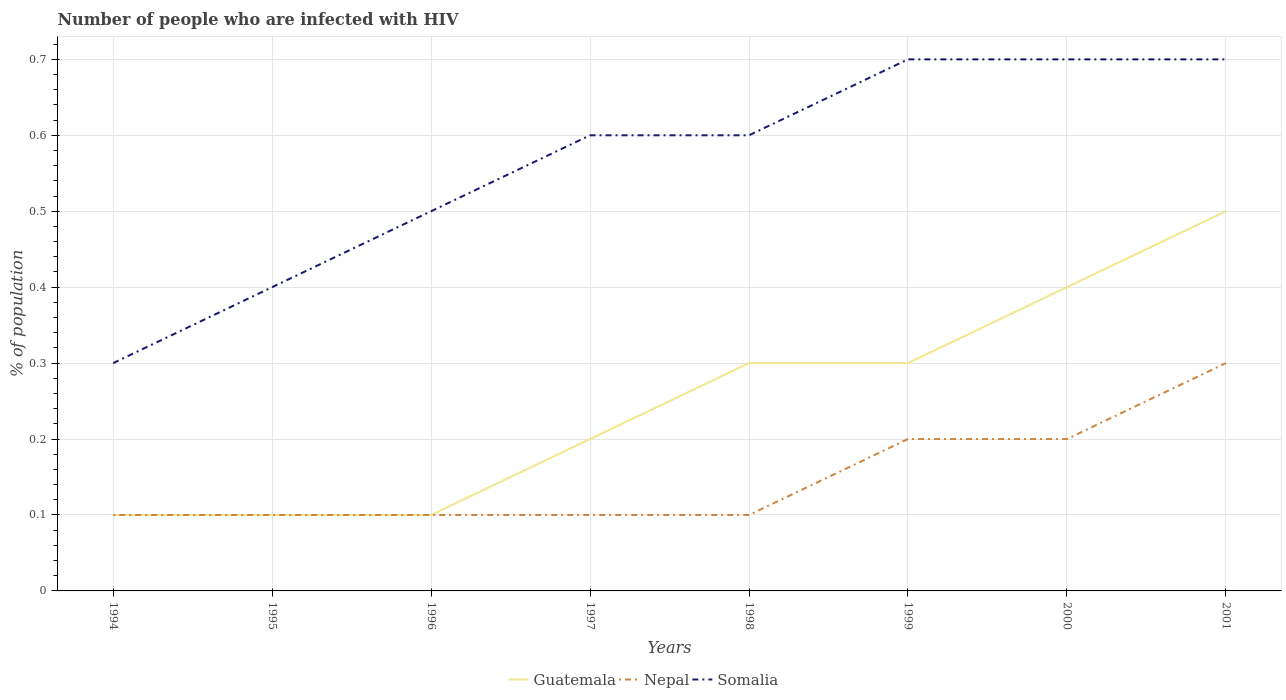How many different coloured lines are there?
Provide a short and direct response. 3. Does the line corresponding to Guatemala intersect with the line corresponding to Somalia?
Your response must be concise. No. Is the number of lines equal to the number of legend labels?
Keep it short and to the point. Yes. Across all years, what is the maximum percentage of HIV infected population in in Nepal?
Keep it short and to the point. 0.1. In which year was the percentage of HIV infected population in in Somalia maximum?
Your response must be concise. 1994. What is the difference between the highest and the second highest percentage of HIV infected population in in Somalia?
Provide a short and direct response. 0.4. What is the difference between the highest and the lowest percentage of HIV infected population in in Somalia?
Keep it short and to the point. 5. How many years are there in the graph?
Your answer should be very brief. 8. What is the difference between two consecutive major ticks on the Y-axis?
Your response must be concise. 0.1. What is the title of the graph?
Your answer should be compact. Number of people who are infected with HIV. What is the label or title of the X-axis?
Your response must be concise. Years. What is the label or title of the Y-axis?
Your response must be concise. % of population. What is the % of population of Guatemala in 1994?
Your response must be concise. 0.1. What is the % of population in Somalia in 1994?
Your answer should be compact. 0.3. What is the % of population of Guatemala in 1995?
Give a very brief answer. 0.1. What is the % of population in Nepal in 1995?
Provide a short and direct response. 0.1. What is the % of population in Somalia in 1995?
Your response must be concise. 0.4. What is the % of population of Nepal in 1996?
Keep it short and to the point. 0.1. What is the % of population of Guatemala in 1997?
Your response must be concise. 0.2. What is the % of population in Nepal in 1997?
Your answer should be very brief. 0.1. What is the % of population in Somalia in 1997?
Provide a short and direct response. 0.6. What is the % of population of Nepal in 1998?
Offer a terse response. 0.1. What is the % of population in Guatemala in 1999?
Your response must be concise. 0.3. What is the % of population of Somalia in 1999?
Give a very brief answer. 0.7. What is the % of population in Somalia in 2000?
Provide a short and direct response. 0.7. Across all years, what is the maximum % of population in Guatemala?
Offer a terse response. 0.5. Across all years, what is the minimum % of population in Nepal?
Give a very brief answer. 0.1. Across all years, what is the minimum % of population in Somalia?
Provide a short and direct response. 0.3. What is the total % of population of Guatemala in the graph?
Offer a terse response. 2. What is the difference between the % of population in Nepal in 1994 and that in 1995?
Your answer should be very brief. 0. What is the difference between the % of population of Somalia in 1994 and that in 1995?
Offer a terse response. -0.1. What is the difference between the % of population of Nepal in 1994 and that in 1996?
Provide a succinct answer. 0. What is the difference between the % of population of Somalia in 1994 and that in 1996?
Offer a very short reply. -0.2. What is the difference between the % of population of Guatemala in 1994 and that in 1997?
Make the answer very short. -0.1. What is the difference between the % of population of Somalia in 1994 and that in 1997?
Provide a succinct answer. -0.3. What is the difference between the % of population of Guatemala in 1994 and that in 1998?
Offer a very short reply. -0.2. What is the difference between the % of population of Guatemala in 1994 and that in 1999?
Your response must be concise. -0.2. What is the difference between the % of population in Nepal in 1994 and that in 1999?
Keep it short and to the point. -0.1. What is the difference between the % of population of Guatemala in 1994 and that in 2000?
Keep it short and to the point. -0.3. What is the difference between the % of population in Somalia in 1994 and that in 2000?
Your answer should be compact. -0.4. What is the difference between the % of population in Somalia in 1994 and that in 2001?
Offer a very short reply. -0.4. What is the difference between the % of population in Nepal in 1995 and that in 1996?
Your response must be concise. 0. What is the difference between the % of population of Guatemala in 1995 and that in 1998?
Your answer should be compact. -0.2. What is the difference between the % of population of Nepal in 1995 and that in 1999?
Provide a succinct answer. -0.1. What is the difference between the % of population in Guatemala in 1995 and that in 2001?
Ensure brevity in your answer.  -0.4. What is the difference between the % of population in Nepal in 1995 and that in 2001?
Keep it short and to the point. -0.2. What is the difference between the % of population of Guatemala in 1996 and that in 1997?
Offer a very short reply. -0.1. What is the difference between the % of population in Somalia in 1996 and that in 1997?
Your answer should be very brief. -0.1. What is the difference between the % of population of Somalia in 1996 and that in 1998?
Make the answer very short. -0.1. What is the difference between the % of population in Guatemala in 1996 and that in 1999?
Provide a succinct answer. -0.2. What is the difference between the % of population of Guatemala in 1996 and that in 2000?
Offer a terse response. -0.3. What is the difference between the % of population of Somalia in 1996 and that in 2000?
Offer a terse response. -0.2. What is the difference between the % of population of Nepal in 1996 and that in 2001?
Your answer should be very brief. -0.2. What is the difference between the % of population in Nepal in 1997 and that in 1999?
Your response must be concise. -0.1. What is the difference between the % of population of Somalia in 1997 and that in 1999?
Offer a terse response. -0.1. What is the difference between the % of population of Somalia in 1997 and that in 2000?
Make the answer very short. -0.1. What is the difference between the % of population of Guatemala in 1997 and that in 2001?
Your answer should be compact. -0.3. What is the difference between the % of population in Nepal in 1997 and that in 2001?
Provide a short and direct response. -0.2. What is the difference between the % of population in Somalia in 1997 and that in 2001?
Your answer should be very brief. -0.1. What is the difference between the % of population of Somalia in 1998 and that in 1999?
Your response must be concise. -0.1. What is the difference between the % of population in Guatemala in 1998 and that in 2000?
Make the answer very short. -0.1. What is the difference between the % of population of Nepal in 1998 and that in 2000?
Provide a succinct answer. -0.1. What is the difference between the % of population in Somalia in 1998 and that in 2001?
Provide a succinct answer. -0.1. What is the difference between the % of population of Guatemala in 1999 and that in 2000?
Offer a very short reply. -0.1. What is the difference between the % of population in Somalia in 1999 and that in 2000?
Offer a very short reply. 0. What is the difference between the % of population of Guatemala in 2000 and that in 2001?
Provide a succinct answer. -0.1. What is the difference between the % of population of Nepal in 2000 and that in 2001?
Ensure brevity in your answer.  -0.1. What is the difference between the % of population of Somalia in 2000 and that in 2001?
Offer a very short reply. 0. What is the difference between the % of population of Guatemala in 1994 and the % of population of Somalia in 1995?
Make the answer very short. -0.3. What is the difference between the % of population of Nepal in 1994 and the % of population of Somalia in 1995?
Ensure brevity in your answer.  -0.3. What is the difference between the % of population in Nepal in 1994 and the % of population in Somalia in 1996?
Your response must be concise. -0.4. What is the difference between the % of population of Guatemala in 1994 and the % of population of Nepal in 1997?
Make the answer very short. 0. What is the difference between the % of population in Guatemala in 1994 and the % of population in Somalia in 1997?
Make the answer very short. -0.5. What is the difference between the % of population in Guatemala in 1994 and the % of population in Somalia in 1998?
Provide a succinct answer. -0.5. What is the difference between the % of population in Nepal in 1994 and the % of population in Somalia in 1998?
Ensure brevity in your answer.  -0.5. What is the difference between the % of population of Guatemala in 1994 and the % of population of Somalia in 1999?
Ensure brevity in your answer.  -0.6. What is the difference between the % of population in Guatemala in 1994 and the % of population in Nepal in 2001?
Keep it short and to the point. -0.2. What is the difference between the % of population in Guatemala in 1994 and the % of population in Somalia in 2001?
Offer a very short reply. -0.6. What is the difference between the % of population in Nepal in 1995 and the % of population in Somalia in 1996?
Your answer should be very brief. -0.4. What is the difference between the % of population in Guatemala in 1995 and the % of population in Nepal in 1998?
Keep it short and to the point. 0. What is the difference between the % of population in Guatemala in 1995 and the % of population in Somalia in 1998?
Your answer should be compact. -0.5. What is the difference between the % of population in Guatemala in 1995 and the % of population in Somalia in 1999?
Ensure brevity in your answer.  -0.6. What is the difference between the % of population of Guatemala in 1995 and the % of population of Nepal in 2000?
Your answer should be compact. -0.1. What is the difference between the % of population in Nepal in 1995 and the % of population in Somalia in 2000?
Keep it short and to the point. -0.6. What is the difference between the % of population in Guatemala in 1995 and the % of population in Nepal in 2001?
Ensure brevity in your answer.  -0.2. What is the difference between the % of population of Guatemala in 1995 and the % of population of Somalia in 2001?
Ensure brevity in your answer.  -0.6. What is the difference between the % of population of Nepal in 1995 and the % of population of Somalia in 2001?
Provide a succinct answer. -0.6. What is the difference between the % of population of Guatemala in 1996 and the % of population of Nepal in 1997?
Ensure brevity in your answer.  0. What is the difference between the % of population of Guatemala in 1996 and the % of population of Somalia in 1997?
Your answer should be compact. -0.5. What is the difference between the % of population in Nepal in 1996 and the % of population in Somalia in 1998?
Offer a terse response. -0.5. What is the difference between the % of population in Nepal in 1996 and the % of population in Somalia in 1999?
Provide a short and direct response. -0.6. What is the difference between the % of population in Guatemala in 1996 and the % of population in Nepal in 2000?
Offer a very short reply. -0.1. What is the difference between the % of population in Nepal in 1996 and the % of population in Somalia in 2000?
Make the answer very short. -0.6. What is the difference between the % of population of Guatemala in 1996 and the % of population of Nepal in 2001?
Give a very brief answer. -0.2. What is the difference between the % of population in Nepal in 1996 and the % of population in Somalia in 2001?
Keep it short and to the point. -0.6. What is the difference between the % of population in Guatemala in 1997 and the % of population in Nepal in 1998?
Keep it short and to the point. 0.1. What is the difference between the % of population of Guatemala in 1997 and the % of population of Nepal in 1999?
Provide a short and direct response. 0. What is the difference between the % of population of Guatemala in 1997 and the % of population of Nepal in 2000?
Make the answer very short. 0. What is the difference between the % of population in Guatemala in 1997 and the % of population in Somalia in 2000?
Ensure brevity in your answer.  -0.5. What is the difference between the % of population of Nepal in 1997 and the % of population of Somalia in 2000?
Your response must be concise. -0.6. What is the difference between the % of population of Guatemala in 1997 and the % of population of Nepal in 2001?
Provide a succinct answer. -0.1. What is the difference between the % of population in Nepal in 1997 and the % of population in Somalia in 2001?
Give a very brief answer. -0.6. What is the difference between the % of population of Guatemala in 1998 and the % of population of Somalia in 1999?
Make the answer very short. -0.4. What is the difference between the % of population in Nepal in 1998 and the % of population in Somalia in 1999?
Your answer should be compact. -0.6. What is the difference between the % of population in Guatemala in 1998 and the % of population in Somalia in 2000?
Make the answer very short. -0.4. What is the difference between the % of population in Guatemala in 1998 and the % of population in Somalia in 2001?
Your answer should be very brief. -0.4. What is the difference between the % of population in Nepal in 1999 and the % of population in Somalia in 2000?
Your answer should be very brief. -0.5. What is the difference between the % of population in Guatemala in 1999 and the % of population in Nepal in 2001?
Provide a succinct answer. 0. What is the difference between the % of population in Guatemala in 1999 and the % of population in Somalia in 2001?
Your answer should be very brief. -0.4. What is the difference between the % of population of Guatemala in 2000 and the % of population of Nepal in 2001?
Keep it short and to the point. 0.1. What is the difference between the % of population of Guatemala in 2000 and the % of population of Somalia in 2001?
Give a very brief answer. -0.3. What is the average % of population in Guatemala per year?
Your answer should be very brief. 0.25. What is the average % of population of Somalia per year?
Ensure brevity in your answer.  0.56. In the year 1994, what is the difference between the % of population of Guatemala and % of population of Nepal?
Provide a succinct answer. 0. In the year 1994, what is the difference between the % of population in Guatemala and % of population in Somalia?
Make the answer very short. -0.2. In the year 1995, what is the difference between the % of population in Nepal and % of population in Somalia?
Keep it short and to the point. -0.3. In the year 1996, what is the difference between the % of population of Guatemala and % of population of Somalia?
Offer a very short reply. -0.4. In the year 1997, what is the difference between the % of population of Guatemala and % of population of Nepal?
Provide a succinct answer. 0.1. In the year 1997, what is the difference between the % of population of Nepal and % of population of Somalia?
Offer a terse response. -0.5. In the year 1998, what is the difference between the % of population of Guatemala and % of population of Nepal?
Offer a terse response. 0.2. In the year 1998, what is the difference between the % of population of Nepal and % of population of Somalia?
Offer a very short reply. -0.5. In the year 1999, what is the difference between the % of population of Guatemala and % of population of Somalia?
Provide a short and direct response. -0.4. In the year 2000, what is the difference between the % of population of Nepal and % of population of Somalia?
Your answer should be very brief. -0.5. In the year 2001, what is the difference between the % of population of Guatemala and % of population of Somalia?
Offer a very short reply. -0.2. What is the ratio of the % of population of Guatemala in 1994 to that in 1995?
Offer a terse response. 1. What is the ratio of the % of population of Nepal in 1994 to that in 1995?
Offer a very short reply. 1. What is the ratio of the % of population of Guatemala in 1994 to that in 1996?
Your response must be concise. 1. What is the ratio of the % of population of Guatemala in 1994 to that in 1997?
Keep it short and to the point. 0.5. What is the ratio of the % of population of Nepal in 1994 to that in 1997?
Your response must be concise. 1. What is the ratio of the % of population of Somalia in 1994 to that in 1997?
Provide a succinct answer. 0.5. What is the ratio of the % of population in Nepal in 1994 to that in 1998?
Keep it short and to the point. 1. What is the ratio of the % of population of Somalia in 1994 to that in 1998?
Keep it short and to the point. 0.5. What is the ratio of the % of population of Guatemala in 1994 to that in 1999?
Keep it short and to the point. 0.33. What is the ratio of the % of population in Somalia in 1994 to that in 1999?
Provide a succinct answer. 0.43. What is the ratio of the % of population in Nepal in 1994 to that in 2000?
Keep it short and to the point. 0.5. What is the ratio of the % of population in Somalia in 1994 to that in 2000?
Offer a terse response. 0.43. What is the ratio of the % of population in Somalia in 1994 to that in 2001?
Keep it short and to the point. 0.43. What is the ratio of the % of population in Somalia in 1995 to that in 1996?
Offer a terse response. 0.8. What is the ratio of the % of population in Guatemala in 1995 to that in 1997?
Your answer should be very brief. 0.5. What is the ratio of the % of population in Guatemala in 1995 to that in 1999?
Keep it short and to the point. 0.33. What is the ratio of the % of population of Guatemala in 1995 to that in 2000?
Provide a short and direct response. 0.25. What is the ratio of the % of population of Nepal in 1995 to that in 2000?
Your answer should be very brief. 0.5. What is the ratio of the % of population of Somalia in 1995 to that in 2001?
Offer a very short reply. 0.57. What is the ratio of the % of population in Nepal in 1996 to that in 1997?
Provide a short and direct response. 1. What is the ratio of the % of population of Somalia in 1996 to that in 1997?
Make the answer very short. 0.83. What is the ratio of the % of population in Guatemala in 1996 to that in 1999?
Offer a very short reply. 0.33. What is the ratio of the % of population in Nepal in 1996 to that in 2000?
Offer a terse response. 0.5. What is the ratio of the % of population in Guatemala in 1996 to that in 2001?
Provide a short and direct response. 0.2. What is the ratio of the % of population of Nepal in 1996 to that in 2001?
Provide a short and direct response. 0.33. What is the ratio of the % of population of Guatemala in 1997 to that in 1998?
Your answer should be very brief. 0.67. What is the ratio of the % of population of Nepal in 1997 to that in 1998?
Ensure brevity in your answer.  1. What is the ratio of the % of population in Guatemala in 1997 to that in 1999?
Provide a short and direct response. 0.67. What is the ratio of the % of population in Somalia in 1997 to that in 1999?
Your answer should be very brief. 0.86. What is the ratio of the % of population of Guatemala in 1997 to that in 2000?
Give a very brief answer. 0.5. What is the ratio of the % of population in Nepal in 1997 to that in 2000?
Make the answer very short. 0.5. What is the ratio of the % of population of Guatemala in 1997 to that in 2001?
Ensure brevity in your answer.  0.4. What is the ratio of the % of population of Nepal in 1997 to that in 2001?
Offer a terse response. 0.33. What is the ratio of the % of population of Somalia in 1998 to that in 1999?
Ensure brevity in your answer.  0.86. What is the ratio of the % of population in Nepal in 1998 to that in 2000?
Ensure brevity in your answer.  0.5. What is the ratio of the % of population in Guatemala in 1999 to that in 2000?
Offer a very short reply. 0.75. What is the ratio of the % of population in Nepal in 1999 to that in 2000?
Your answer should be very brief. 1. What is the ratio of the % of population of Somalia in 1999 to that in 2000?
Your answer should be compact. 1. What is the ratio of the % of population of Somalia in 1999 to that in 2001?
Offer a very short reply. 1. What is the ratio of the % of population in Somalia in 2000 to that in 2001?
Ensure brevity in your answer.  1. What is the difference between the highest and the second highest % of population of Nepal?
Your answer should be compact. 0.1. What is the difference between the highest and the lowest % of population of Guatemala?
Your answer should be very brief. 0.4. What is the difference between the highest and the lowest % of population in Nepal?
Offer a very short reply. 0.2. 